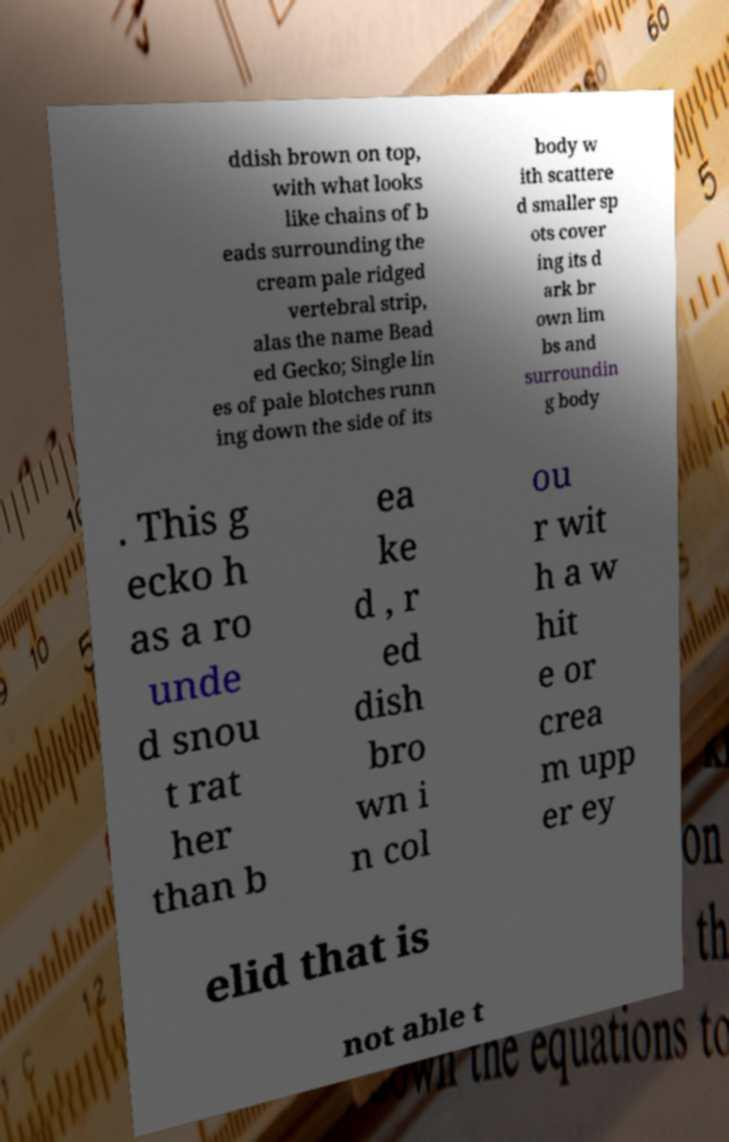I need the written content from this picture converted into text. Can you do that? ddish brown on top, with what looks like chains of b eads surrounding the cream pale ridged vertebral strip, alas the name Bead ed Gecko; Single lin es of pale blotches runn ing down the side of its body w ith scattere d smaller sp ots cover ing its d ark br own lim bs and surroundin g body . This g ecko h as a ro unde d snou t rat her than b ea ke d , r ed dish bro wn i n col ou r wit h a w hit e or crea m upp er ey elid that is not able t 